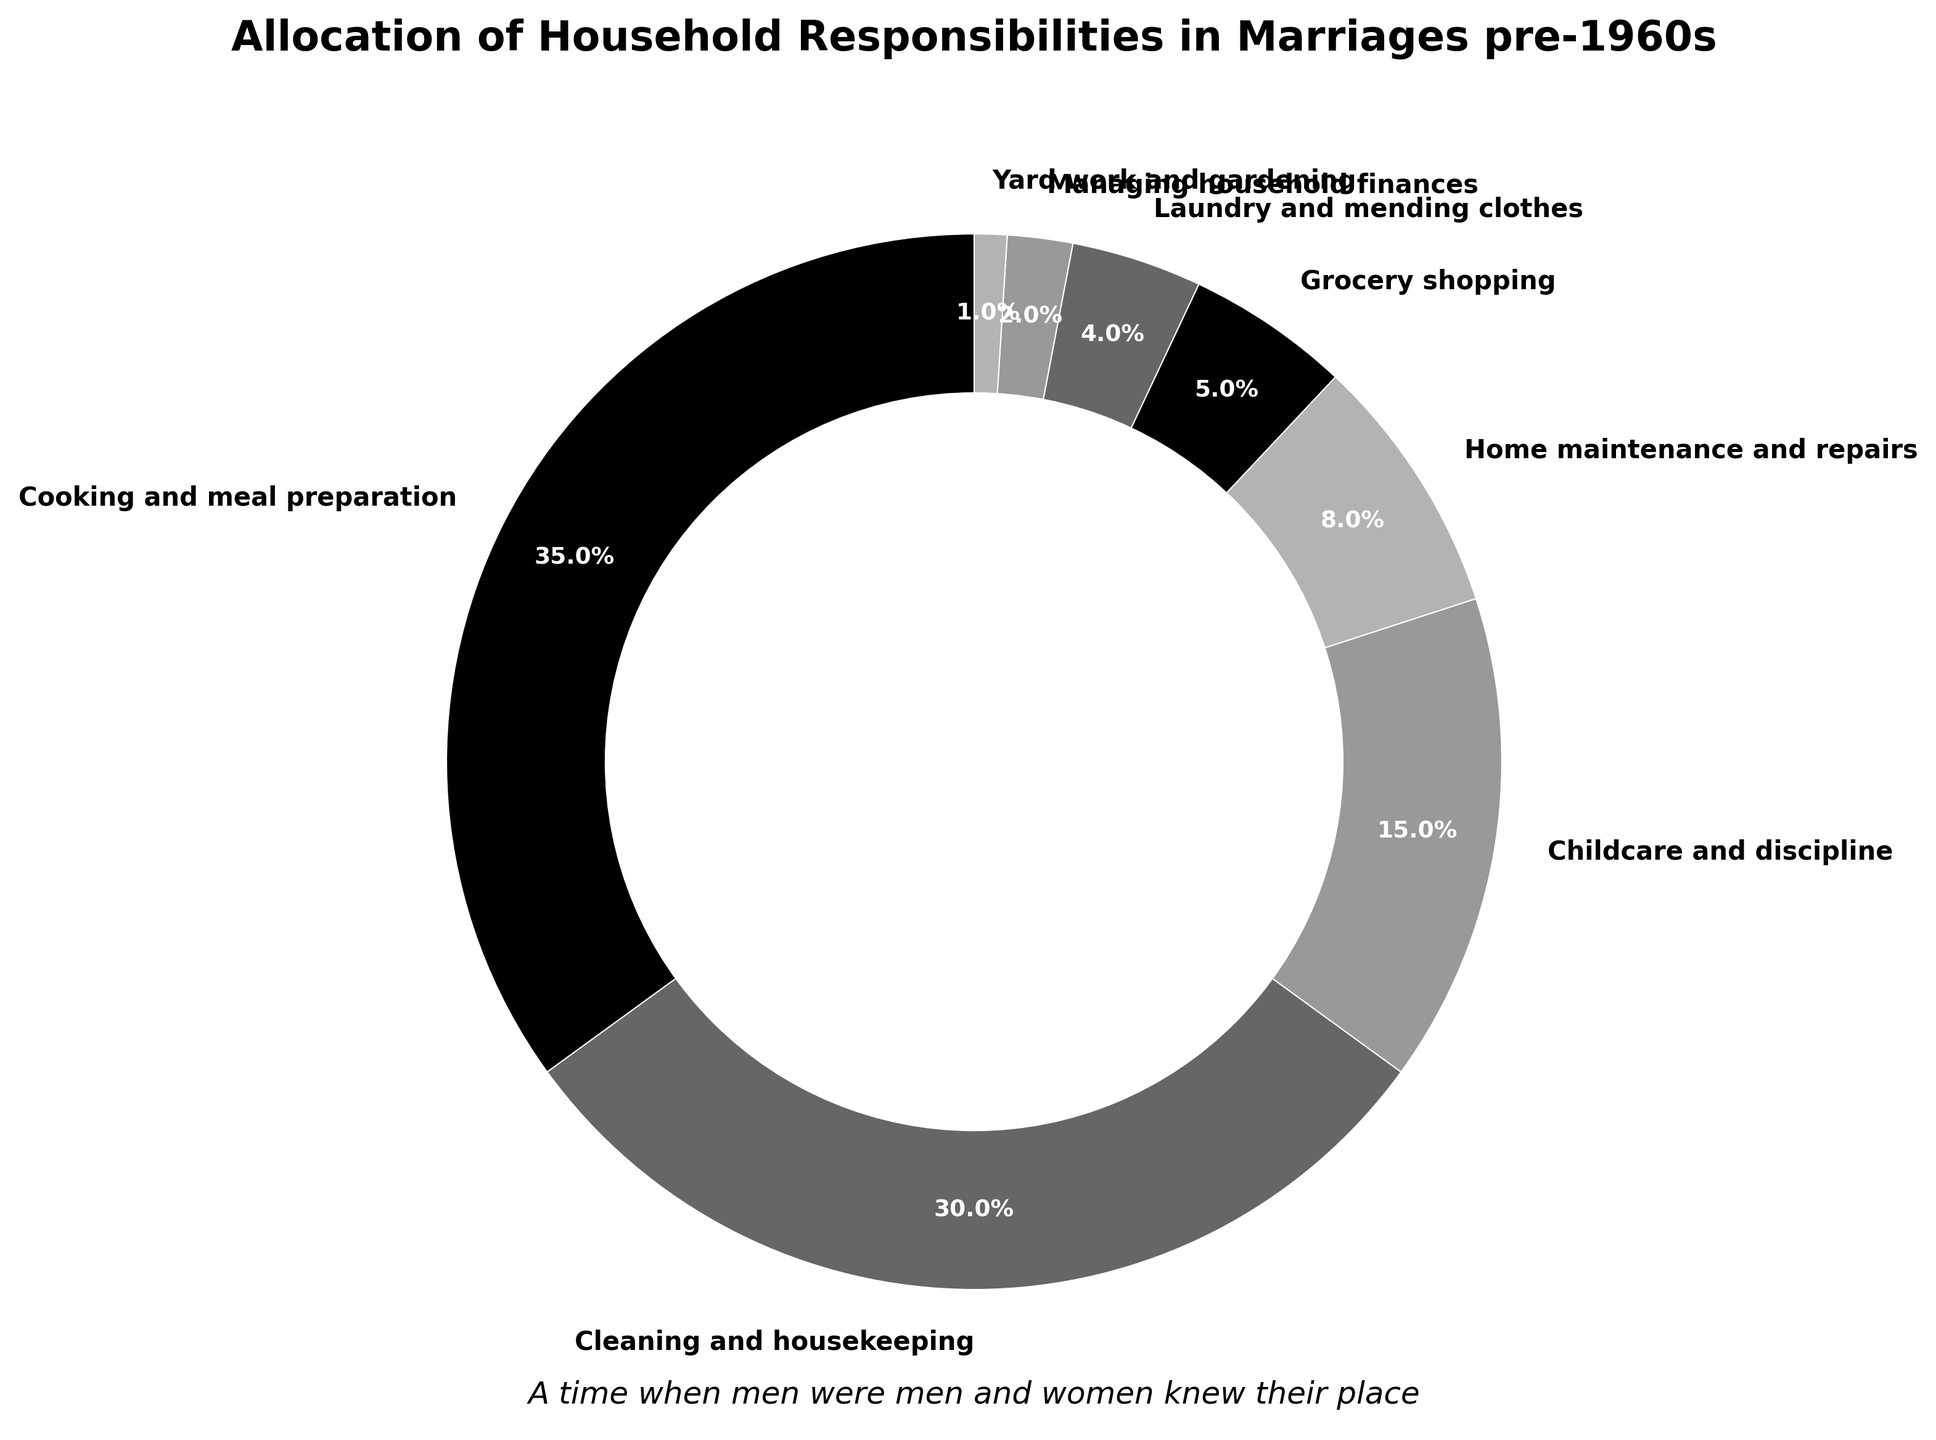Which task has the highest percentage allocation? By inspecting the pie chart, we see that "Cooking and meal preparation" corresponds to the largest segment of the pie, which indicates it has the highest percentage.
Answer: Cooking and meal preparation What is the combined percentage of Cleaning and housekeeping and Childcare and discipline? The pie chart shows that Cleaning and housekeeping is 30% and Childcare and discipline is 15%. Adding these percentages gives us 30% + 15% = 45%.
Answer: 45% Which housekeeping task accounts for the smallest proportion? From the pie chart, the smallest segment is labeled as "Yard work and gardening" which has the lowest percentage allocation.
Answer: Yard work and gardening Is the percentage allocated to Laundry and mending clothes greater than that allocated to Managing household finances? The pie chart indicates that Laundry and mending clothes has a percentage of 4% while Managing household finances has a percentage of 2%. Since 4% is greater than 2%, the answer is yes.
Answer: Yes How much more time is allocated to Cooking and meal preparation compared to Home maintenance and repairs? The pie chart shows Cooking and meal preparation is 35% and Home maintenance and repairs is 8%. Subtracting 8 from 35, we get 35% - 8% = 27%.
Answer: 27% What is the average percentage for Grocery shopping and Yard work and gardening? According to the pie chart, Grocery shopping is 5% and Yard work and gardening is 1%. The average of these two percentages is (5% + 1%) / 2 = 6% / 2 = 3%.
Answer: 3% Which activities combined make up nearly half of the total responsibilities? The pie chart indicates that Cleaning and housekeeping (30%) and Cooking and meal preparation (35%) together make up 30% + 35% = 65%. These two form a large majority, but not just under half. Childcare and discipline (15%) and Cleaning and housekeeping (30%) together make up 45%, which is nearly half.
Answer: Cleaning and housekeeping and Childcare and discipline Is the allocation for Home maintenance and repairs closer to that for Cooking and meal preparation or Cleaning and housekeeping? From the pie chart, Home maintenance and repairs is 8%, Cooking and meal preparation is 35%, and Cleaning and housekeeping is 30%. The difference between Home maintenance and repairs and Cooking is 35% - 8% = 27%, and the difference between Home maintenance and Cleaning is 30% - 8% = 22%. Since 22% is less than 27%, Home maintenance and repairs is closer to Cleaning and housekeeping.
Answer: Cleaning and housekeeping 